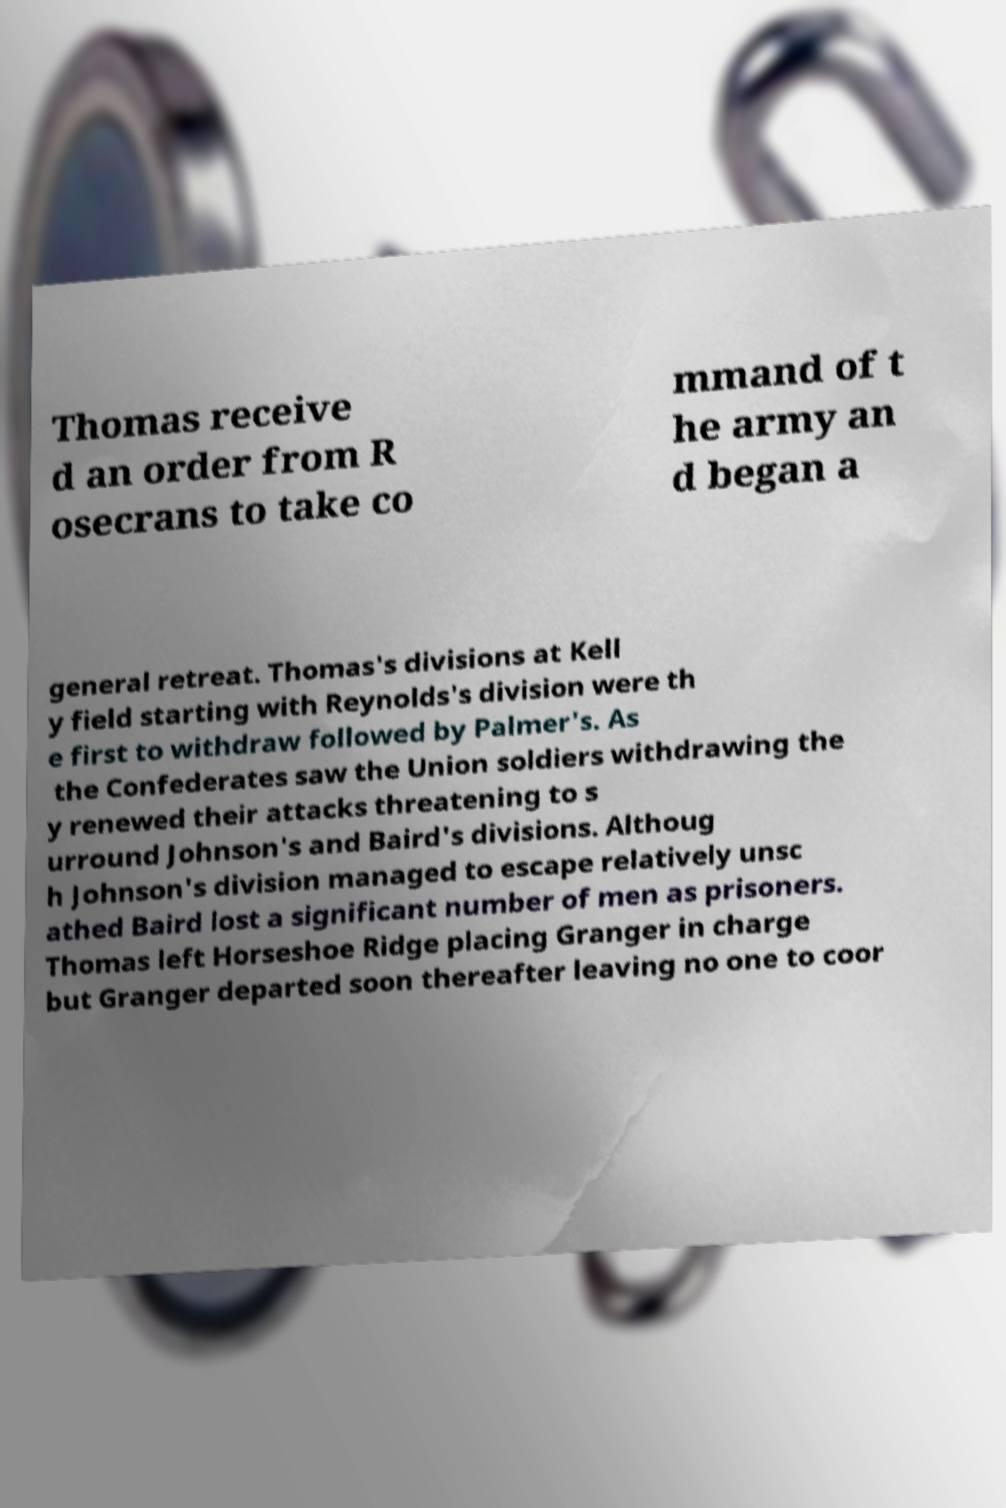For documentation purposes, I need the text within this image transcribed. Could you provide that? Thomas receive d an order from R osecrans to take co mmand of t he army an d began a general retreat. Thomas's divisions at Kell y field starting with Reynolds's division were th e first to withdraw followed by Palmer's. As the Confederates saw the Union soldiers withdrawing the y renewed their attacks threatening to s urround Johnson's and Baird's divisions. Althoug h Johnson's division managed to escape relatively unsc athed Baird lost a significant number of men as prisoners. Thomas left Horseshoe Ridge placing Granger in charge but Granger departed soon thereafter leaving no one to coor 